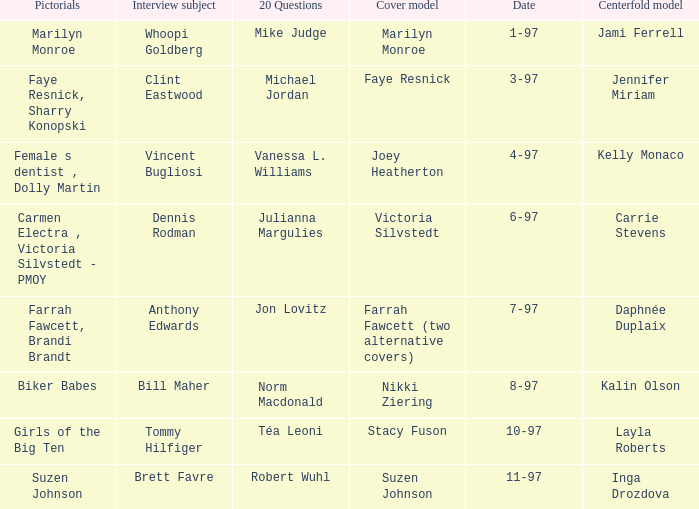Can you parse all the data within this table? {'header': ['Pictorials', 'Interview subject', '20 Questions', 'Cover model', 'Date', 'Centerfold model'], 'rows': [['Marilyn Monroe', 'Whoopi Goldberg', 'Mike Judge', 'Marilyn Monroe', '1-97', 'Jami Ferrell'], ['Faye Resnick, Sharry Konopski', 'Clint Eastwood', 'Michael Jordan', 'Faye Resnick', '3-97', 'Jennifer Miriam'], ['Female s dentist , Dolly Martin', 'Vincent Bugliosi', 'Vanessa L. Williams', 'Joey Heatherton', '4-97', 'Kelly Monaco'], ['Carmen Electra , Victoria Silvstedt - PMOY', 'Dennis Rodman', 'Julianna Margulies', 'Victoria Silvstedt', '6-97', 'Carrie Stevens'], ['Farrah Fawcett, Brandi Brandt', 'Anthony Edwards', 'Jon Lovitz', 'Farrah Fawcett (two alternative covers)', '7-97', 'Daphnée Duplaix'], ['Biker Babes', 'Bill Maher', 'Norm Macdonald', 'Nikki Ziering', '8-97', 'Kalin Olson'], ['Girls of the Big Ten', 'Tommy Hilfiger', 'Téa Leoni', 'Stacy Fuson', '10-97', 'Layla Roberts'], ['Suzen Johnson', 'Brett Favre', 'Robert Wuhl', 'Suzen Johnson', '11-97', 'Inga Drozdova']]} Who was the centerfold model when a pictorial was done on marilyn monroe? Jami Ferrell. 